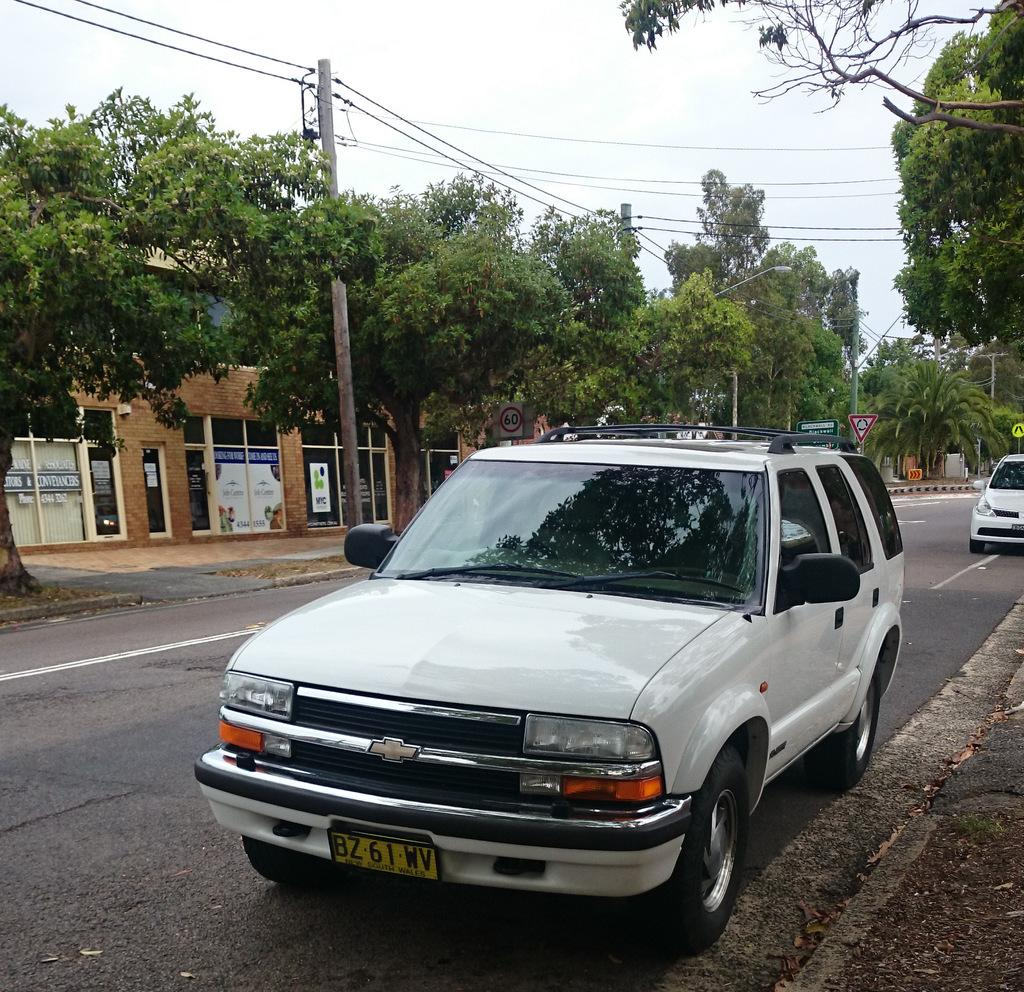How many cars are on the road in the image? There are two cars on the road in the image. What can be seen in the background of the image? The sky is visible in the background of the image. What type of structures are present in the image? There is a building with posters on the glass in the image. What else can be seen on the road besides the cars? There are sign boards and a pole with wires in the image. Are there any trees visible in the image? Yes, there are trees visible in the image. What type of humor is being displayed on the sign boards in the image? There is no humor displayed on the sign boards in the image; they are likely to contain information or instructions. Is there a competition taking place between the two cars in the image? There is no indication of a competition between the two cars in the image; they are simply driving on the road. 